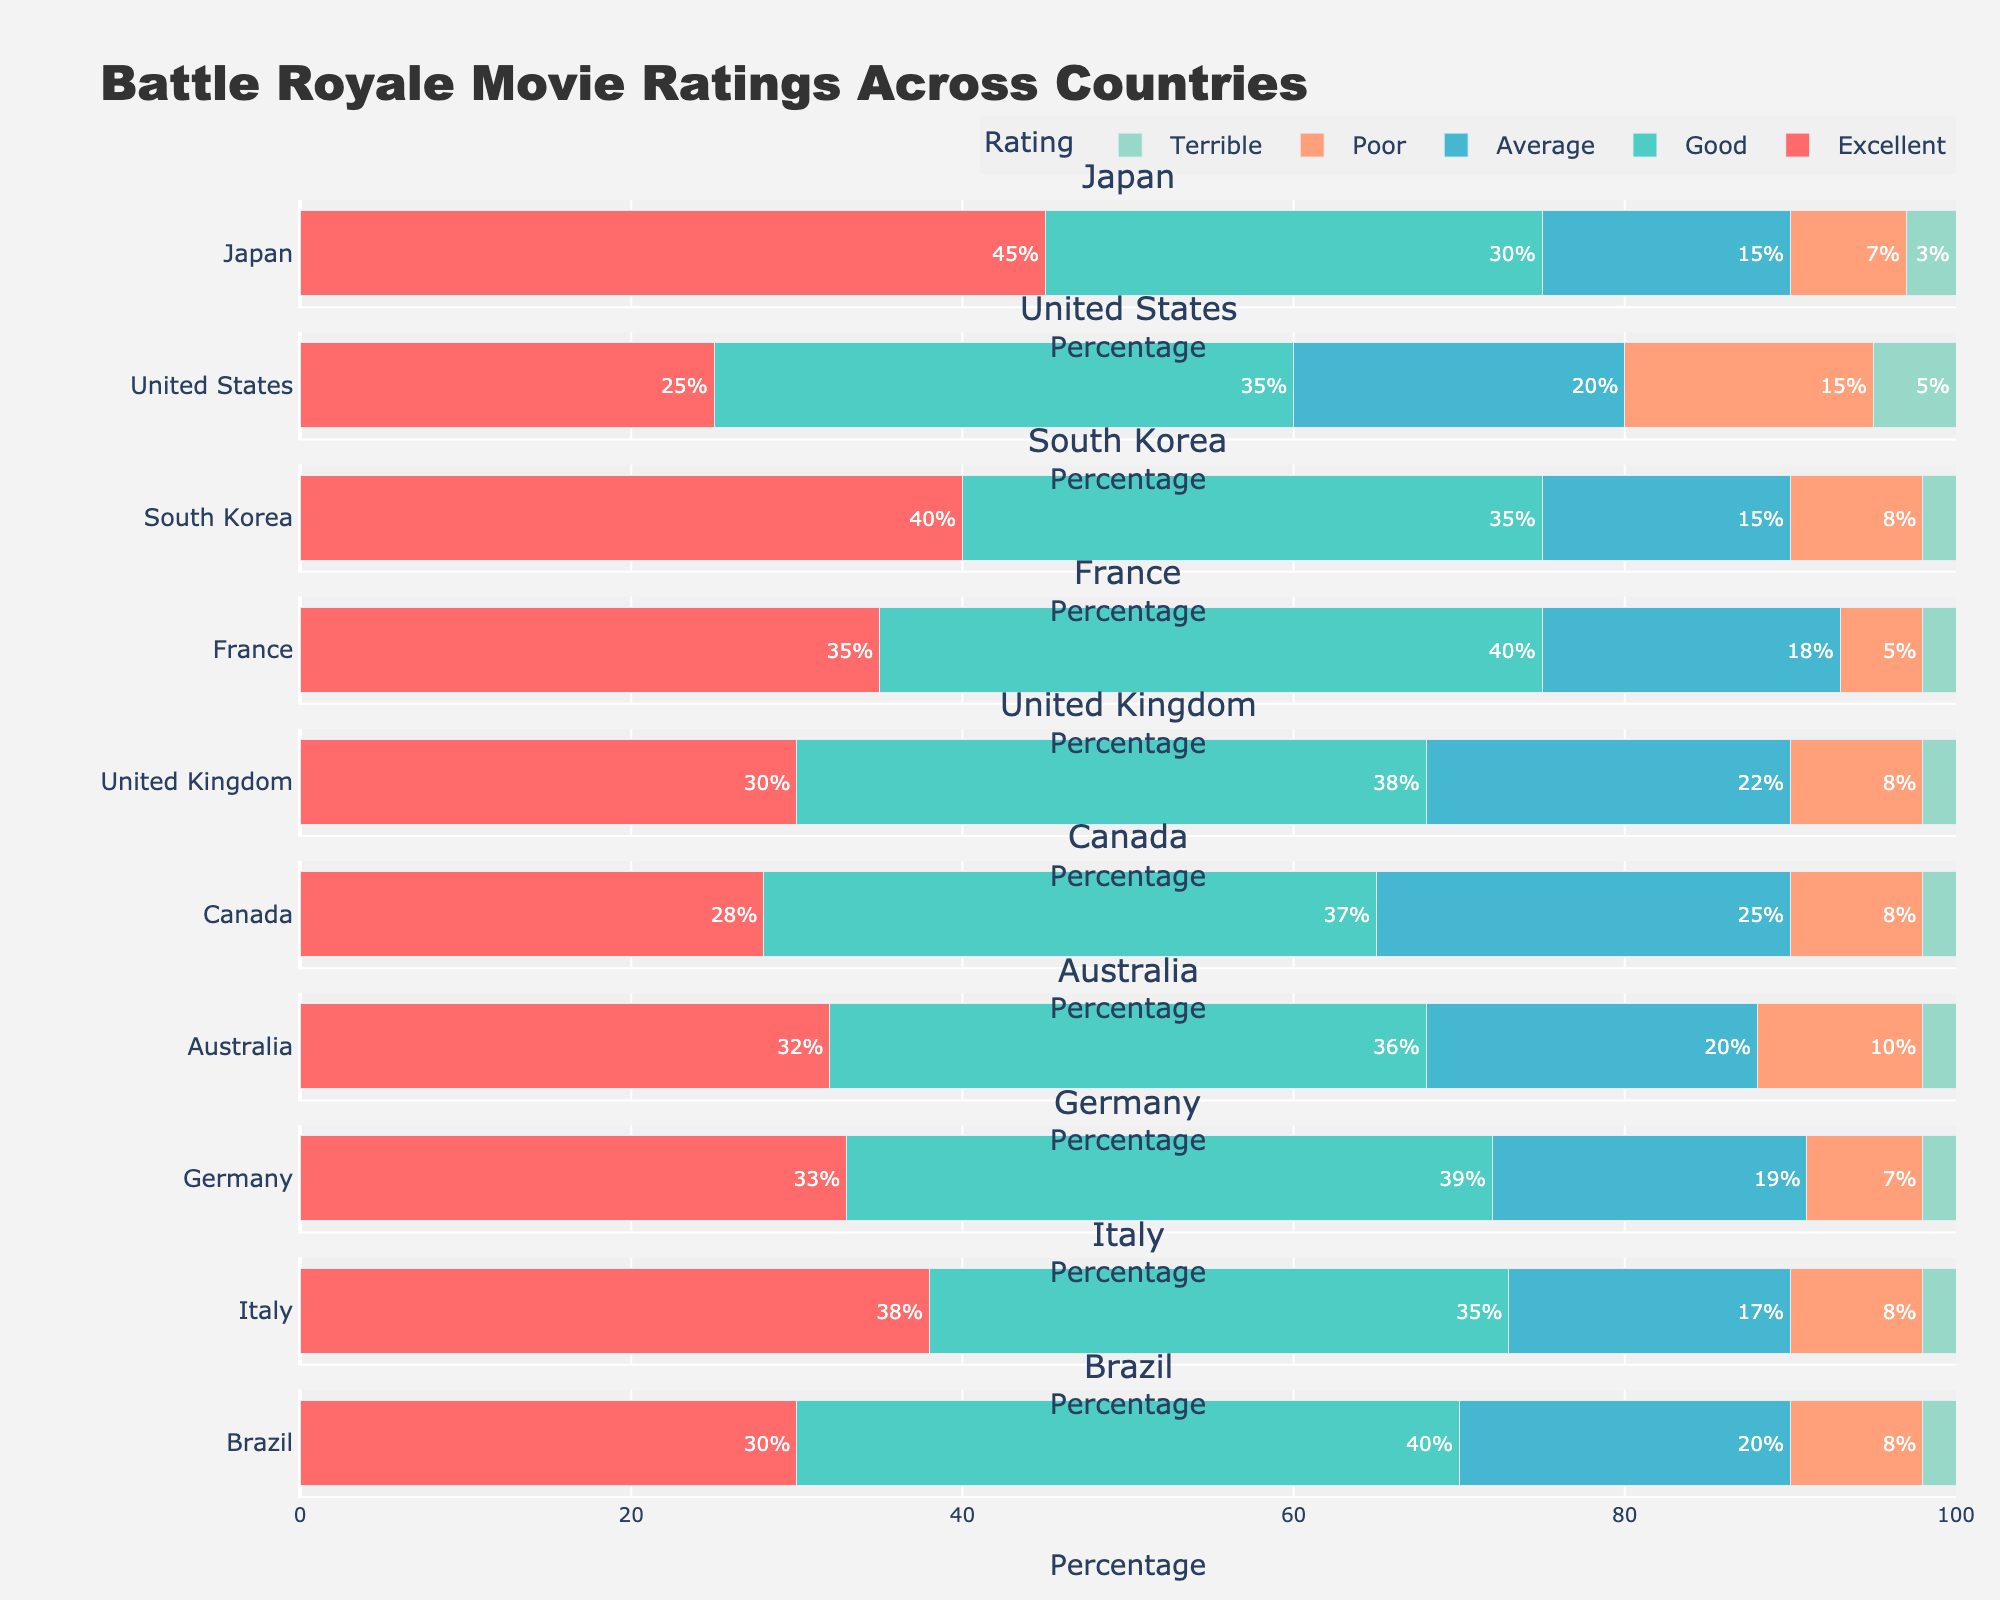what is the title of this figure? The title of the figure is displayed at the very top of the plot. It reads "Battle Royale Movie Ratings Across Countries".
Answer: Battle Royale Movie Ratings Across Countries which country has the highest percentage of excellent ratings? To determine which country has the highest percentage of Excellent ratings, you need to look at the bar segment for Excellent in each subplot. Japan has the longest bar for Excellent ratings at 45%.
Answer: Japan compare the percentage of good ratings between the united states and france. Which one is higher? We need to look at the Good rating bars for both these countries. The United States has 35% Good ratings, while France has 40%, making France's percentage higher.
Answer: France what is the combined percentage of average and poor ratings for australia? For Australia, the Average rating is 20% and the Poor rating is 10%. Adding these together, we get 20% + 10% = 30%.
Answer: 30% which three countries have the same percentage of poor ratings? We need to look at the Poor rating bars for all countries and identify those with the same length. France, Italy, and Brazil each have a Poor rating of 8%.
Answer: France, Italy, Brazil how does the percentage of excellent ratings in germany compare to the united kingdom? The subplot for Germany shows 33% Excellent ratings. The subplot for the United Kingdom shows 30% Excellent ratings. Therefore, Germany has a higher percentage than the United Kingdom.
Answer: Germany has a higher percentage what is the total percentage of terrible ratings across all countries? Sum the Terrible ratings from each country: 3 (Japan) + 5 (United States) + 2 (South Korea) + 2 (France) + 2 (United Kingdom) + 2 (Canada) + 2 (Australia) + 2 (Germany) + 2 (Italy) + 2 (Brazil) = 24%.
Answer: 24% which country has the most evenly distributed ratings? An even distribution means that the ratings are spread almost equally. Canada, with ratings of 28%, 37%, 25%, 8%, and 2%, shows the most balance among the five rating categories.
Answer: Canada what color represents the good rating in the figure? The Good rating bars across all subplots are colored using the second color listed, which is a teal or turquoise color.
Answer: Teal/Turquoise is there any country where poor and terrible ratings combined exceed the average rating? For each country, add Poor and Terrible ratings and compare to the Average rating. For the United States, Poor (15%) + Terrible (5%) = 20%, which is equal to the Average rating of 20%. No country has combined Poor and Terrible ratings exceeding the Average rating.
Answer: No 